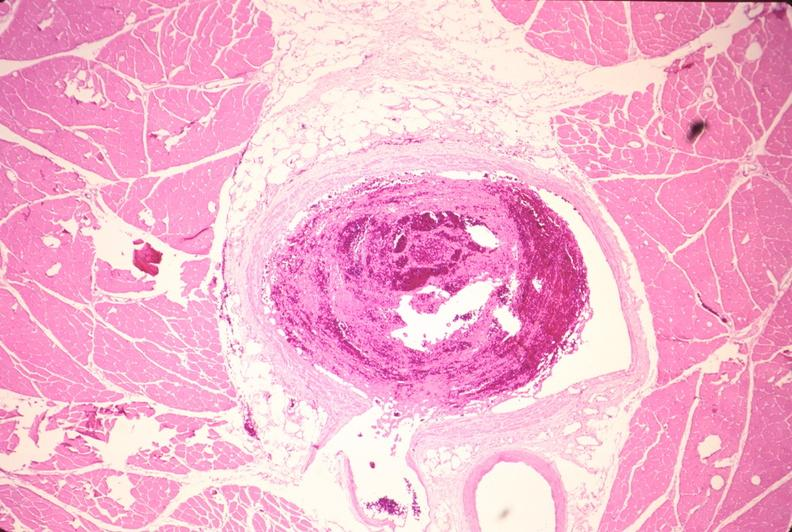s beckwith-wiedemann syndrome present?
Answer the question using a single word or phrase. No 